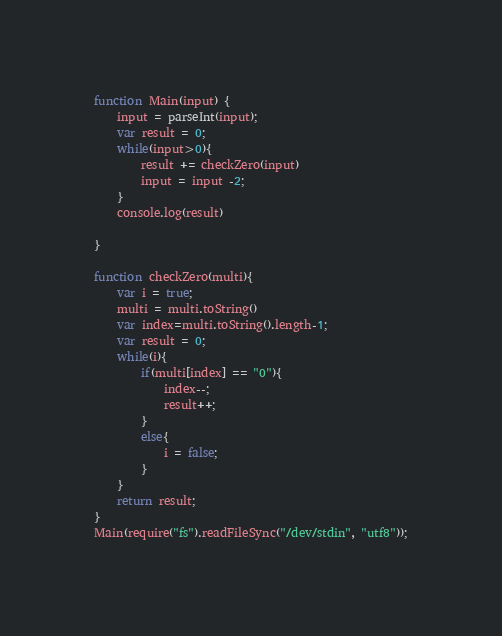<code> <loc_0><loc_0><loc_500><loc_500><_JavaScript_>function Main(input) {
    input = parseInt(input);
    var result = 0;
    while(input>0){
        result += checkZero(input)
        input = input -2;
    }
    console.log(result)
 
}
 
function checkZero(multi){
    var i = true;
    multi = multi.toString()
    var index=multi.toString().length-1;
    var result = 0;
    while(i){
        if(multi[index] == "0"){
            index--;
            result++;
        }
        else{
            i = false;
        }
    }
    return result;
}
Main(require("fs").readFileSync("/dev/stdin", "utf8"));</code> 